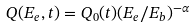Convert formula to latex. <formula><loc_0><loc_0><loc_500><loc_500>Q ( E _ { e } , t ) = Q _ { 0 } ( t ) ( E _ { e } / E _ { b } ) ^ { - \alpha }</formula> 